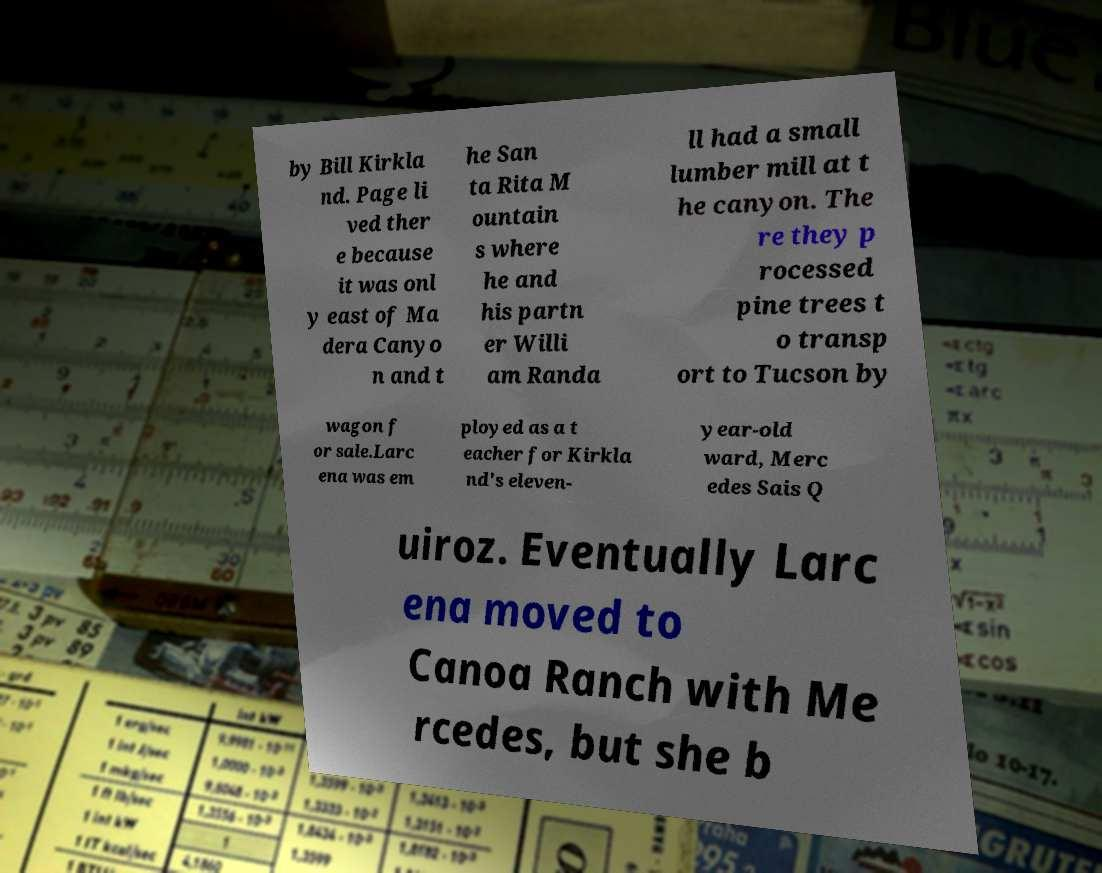Can you read and provide the text displayed in the image?This photo seems to have some interesting text. Can you extract and type it out for me? by Bill Kirkla nd. Page li ved ther e because it was onl y east of Ma dera Canyo n and t he San ta Rita M ountain s where he and his partn er Willi am Randa ll had a small lumber mill at t he canyon. The re they p rocessed pine trees t o transp ort to Tucson by wagon f or sale.Larc ena was em ployed as a t eacher for Kirkla nd's eleven- year-old ward, Merc edes Sais Q uiroz. Eventually Larc ena moved to Canoa Ranch with Me rcedes, but she b 